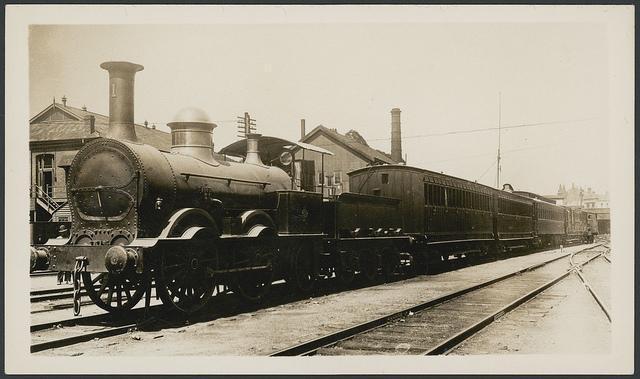How many trains are there?
Give a very brief answer. 1. How many depictions of a dog can be seen?
Give a very brief answer. 0. 